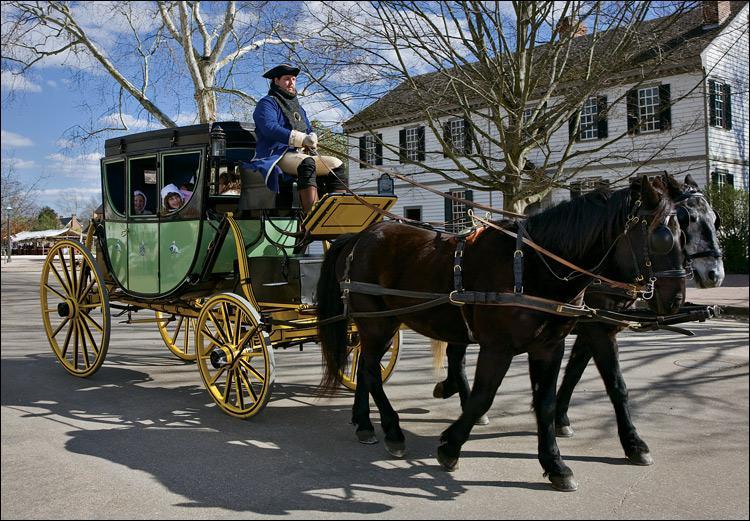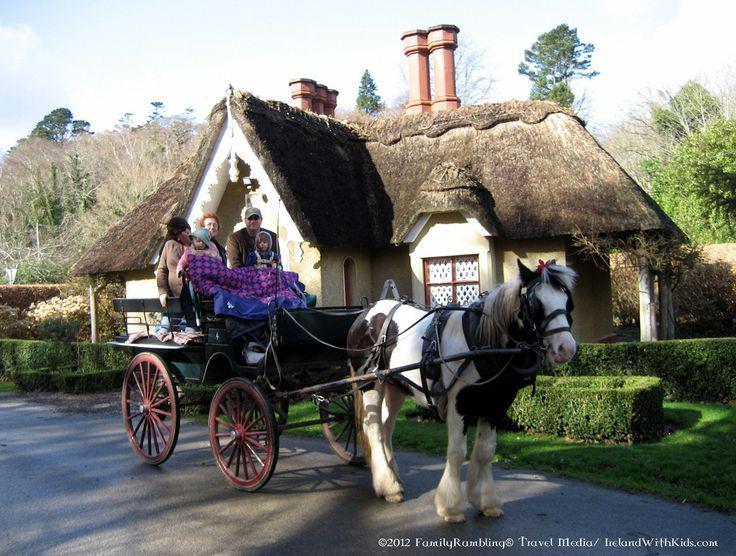The first image is the image on the left, the second image is the image on the right. For the images shown, is this caption "Right image shows a four-wheeled cart puled by one horse." true? Answer yes or no. Yes. The first image is the image on the left, the second image is the image on the right. Assess this claim about the two images: "a brown horse pulls a small carriage with 2 people on it". Correct or not? Answer yes or no. No. 